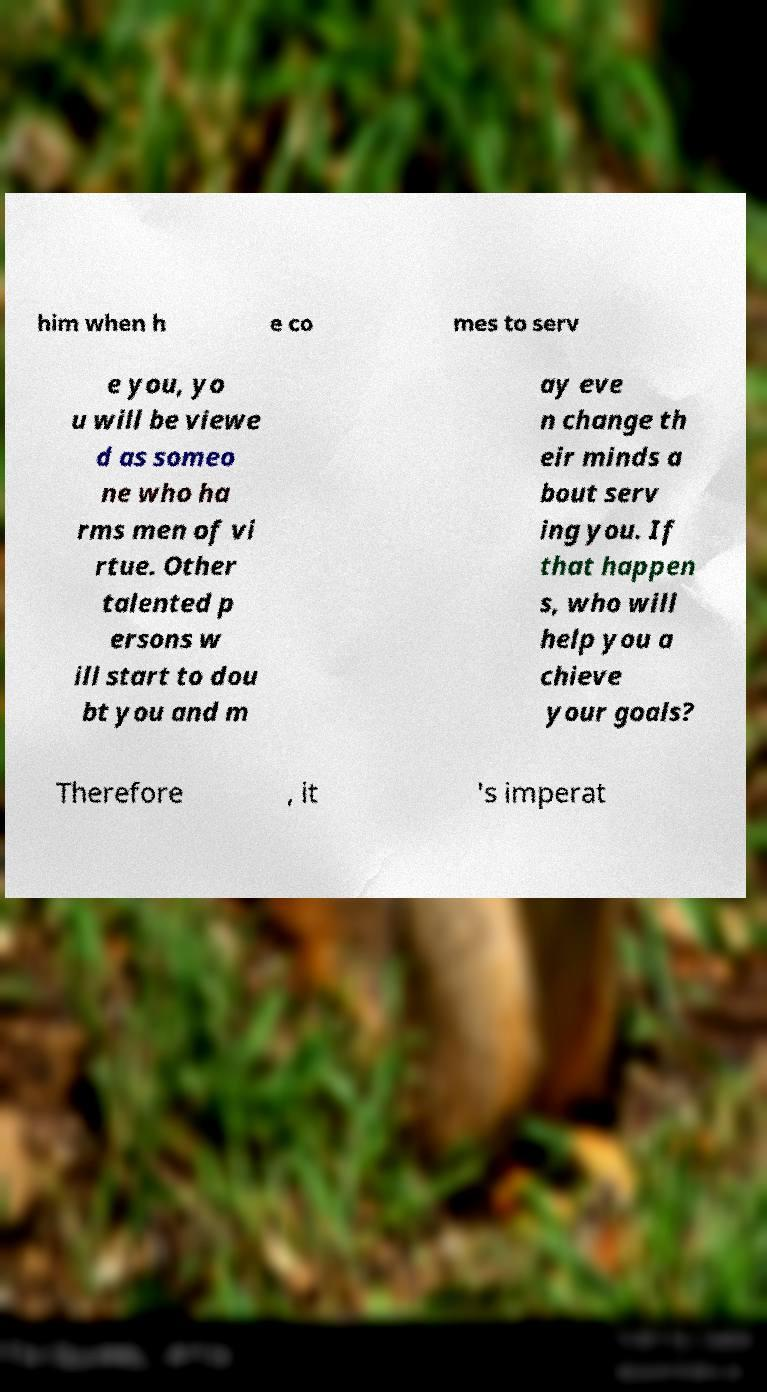Can you read and provide the text displayed in the image?This photo seems to have some interesting text. Can you extract and type it out for me? him when h e co mes to serv e you, yo u will be viewe d as someo ne who ha rms men of vi rtue. Other talented p ersons w ill start to dou bt you and m ay eve n change th eir minds a bout serv ing you. If that happen s, who will help you a chieve your goals? Therefore , it 's imperat 